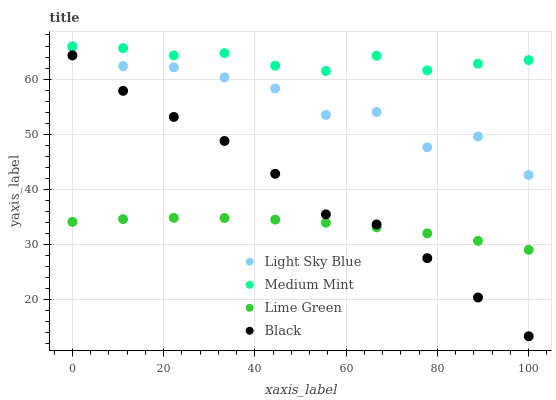Does Lime Green have the minimum area under the curve?
Answer yes or no. Yes. Does Medium Mint have the maximum area under the curve?
Answer yes or no. Yes. Does Black have the minimum area under the curve?
Answer yes or no. No. Does Black have the maximum area under the curve?
Answer yes or no. No. Is Lime Green the smoothest?
Answer yes or no. Yes. Is Light Sky Blue the roughest?
Answer yes or no. Yes. Is Black the smoothest?
Answer yes or no. No. Is Black the roughest?
Answer yes or no. No. Does Black have the lowest value?
Answer yes or no. Yes. Does Light Sky Blue have the lowest value?
Answer yes or no. No. Does Light Sky Blue have the highest value?
Answer yes or no. Yes. Does Black have the highest value?
Answer yes or no. No. Is Black less than Light Sky Blue?
Answer yes or no. Yes. Is Medium Mint greater than Black?
Answer yes or no. Yes. Does Medium Mint intersect Light Sky Blue?
Answer yes or no. Yes. Is Medium Mint less than Light Sky Blue?
Answer yes or no. No. Is Medium Mint greater than Light Sky Blue?
Answer yes or no. No. Does Black intersect Light Sky Blue?
Answer yes or no. No. 